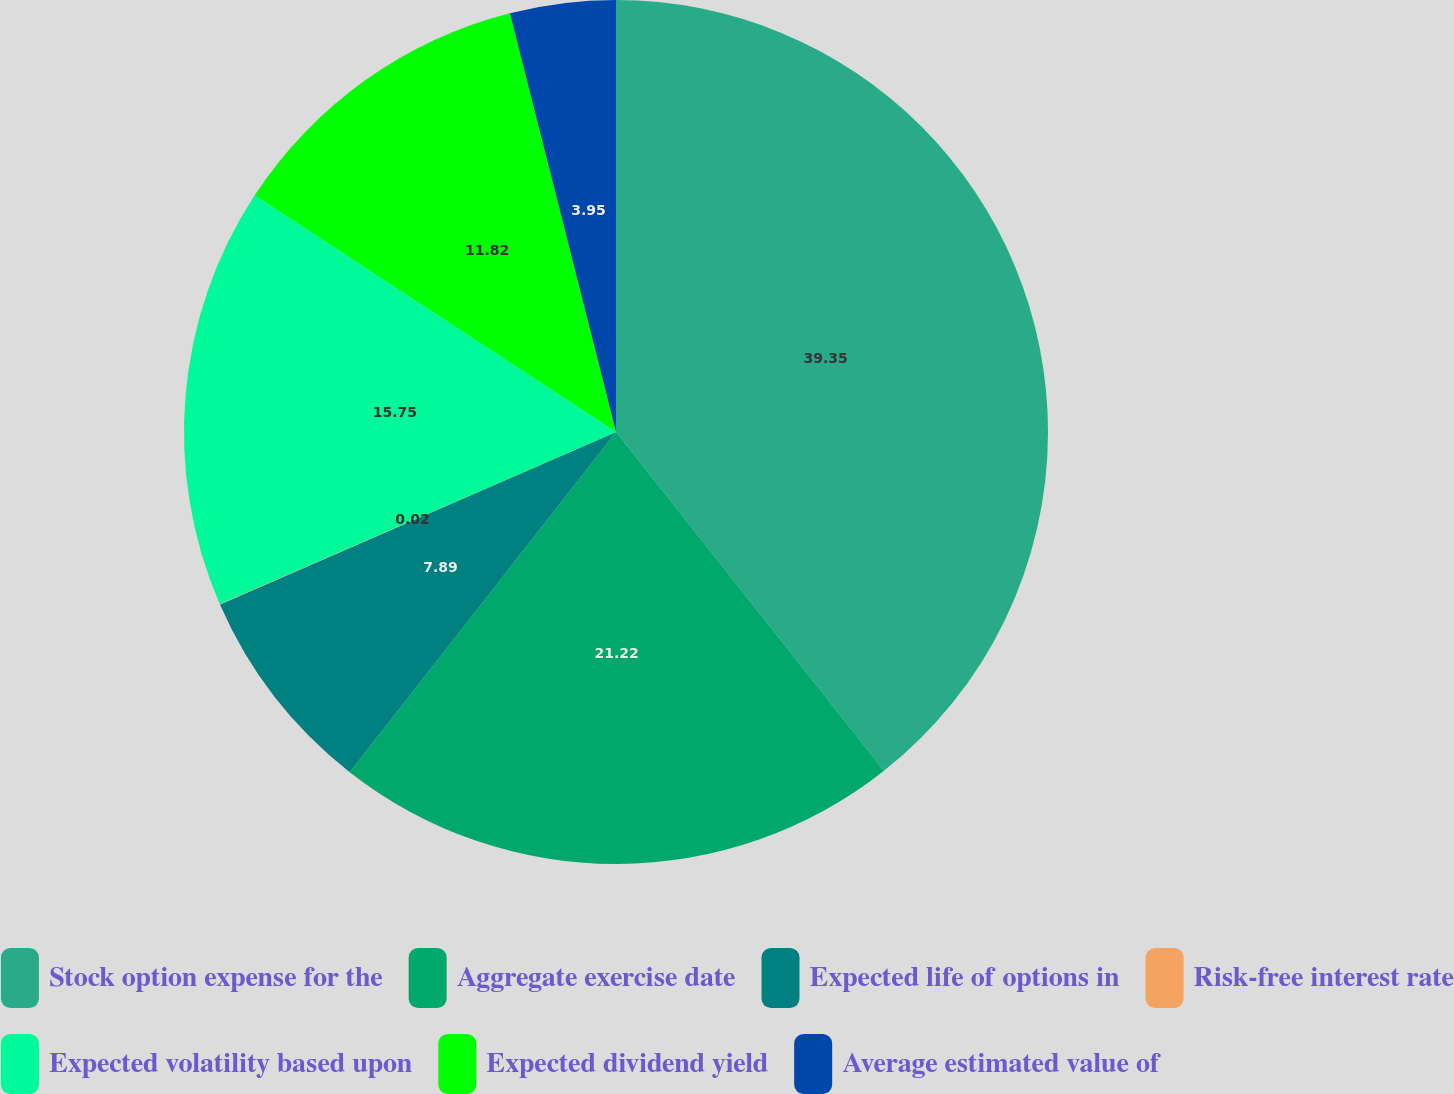<chart> <loc_0><loc_0><loc_500><loc_500><pie_chart><fcel>Stock option expense for the<fcel>Aggregate exercise date<fcel>Expected life of options in<fcel>Risk-free interest rate<fcel>Expected volatility based upon<fcel>Expected dividend yield<fcel>Average estimated value of<nl><fcel>39.35%<fcel>21.22%<fcel>7.89%<fcel>0.02%<fcel>15.75%<fcel>11.82%<fcel>3.95%<nl></chart> 